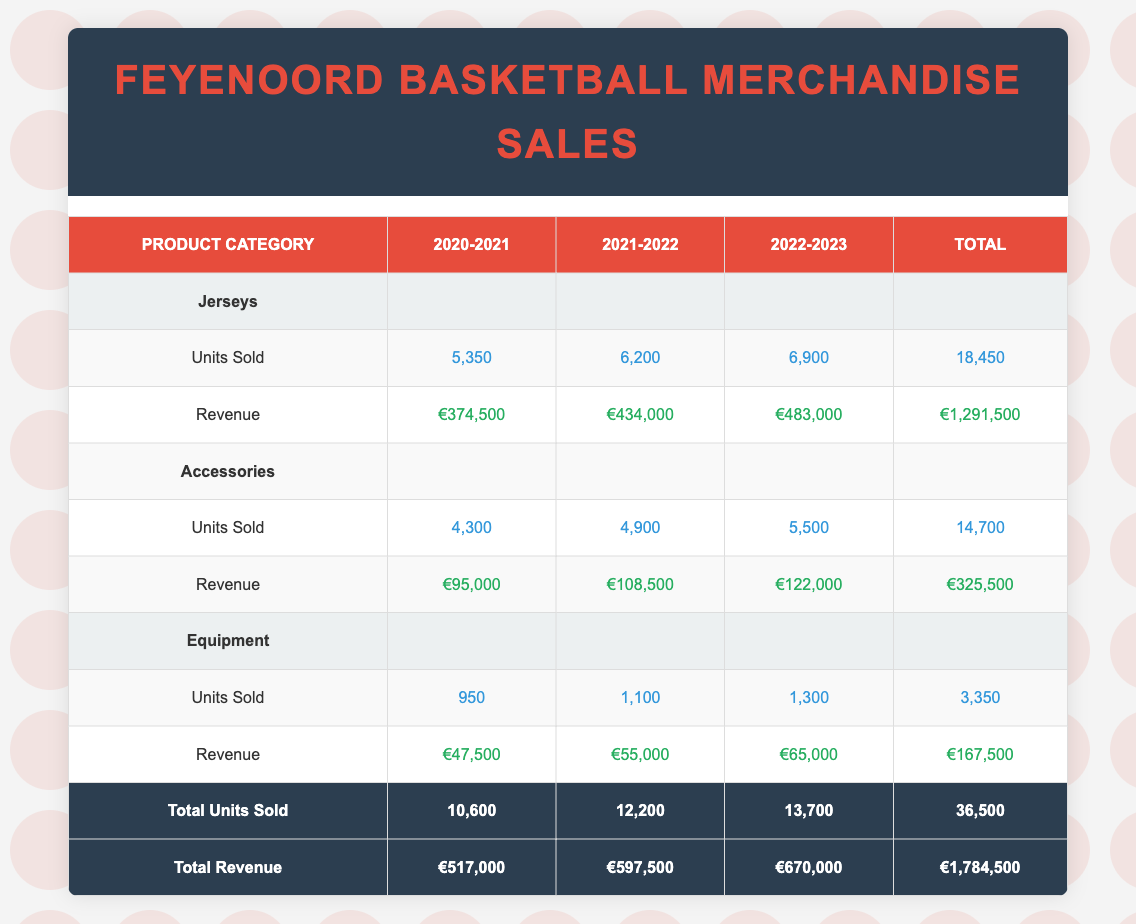What is the total revenue from merchandise sales in the 2022-2023 season? The total revenue for the 2022-2023 season can be found in the table under the Revenue row for that season. It shows a value of €670,000.
Answer: €670,000 How many units of accessories were sold from 2020-2021 to 2022-2023? To find the total units sold for accessories, sum the units sold across the three seasons: 4,300 + 4,900 + 5,500 = 14,700.
Answer: 14,700 Which product category had the highest total revenue over the three seasons? By comparing total revenues from each product category: Jerseys (€1,291,500), Accessories (€325,500), Equipment (€167,500). Jerseys have the highest total revenue.
Answer: Jerseys Was there an increase in the number of units sold for jerseys from the 2021-2022 to the 2022-2023 season? For 2021-2022, units sold were 6,200, and for 2022-2023, they were 6,900. Since 6,900 is greater than 6,200, there was indeed an increase.
Answer: Yes What is the average revenue per season for the Equipment category? The total revenue for Equipment over the three seasons is €167,500. There are three seasons, so average revenue is €167,500 / 3 = €55,833.33.
Answer: €55,833.33 In which season was the Feyenoord Basketball Cap sold the most? Reviewing the units sold for the Feyenoord Basketball Cap: 1,800 in 2020-2021, 2,100 in 2021-2022, and 2,400 in 2022-2023. The highest number is 2,400 in the 2022-2023 season.
Answer: 2022-2023 How much more revenue did Jerseys generate compared to Equipment in the 2021-2022 season? Total revenue for Jerseys in 2021-2022 was €434,000 and for Equipment it was €55,000. The difference is €434,000 - €55,000 = €379,000.
Answer: €379,000 Did total units sold increase every year across all product categories? The total units sold for each season were: 10,600 (2020-2021), 12,200 (2021-2022), and 13,700 (2022-2023). All numbers are in increasing order, denoting an increase each year.
Answer: Yes What proportion of total revenue does Accessories contribute in the 2022-2023 season? The revenue for Accessories in 2022-2023 is €122,000, and the total revenue for all categories in that season is €670,000. Proportion is €122,000 / €670,000 = 0.181. Thus, it contributes approximately 18.1%.
Answer: 18.1% 